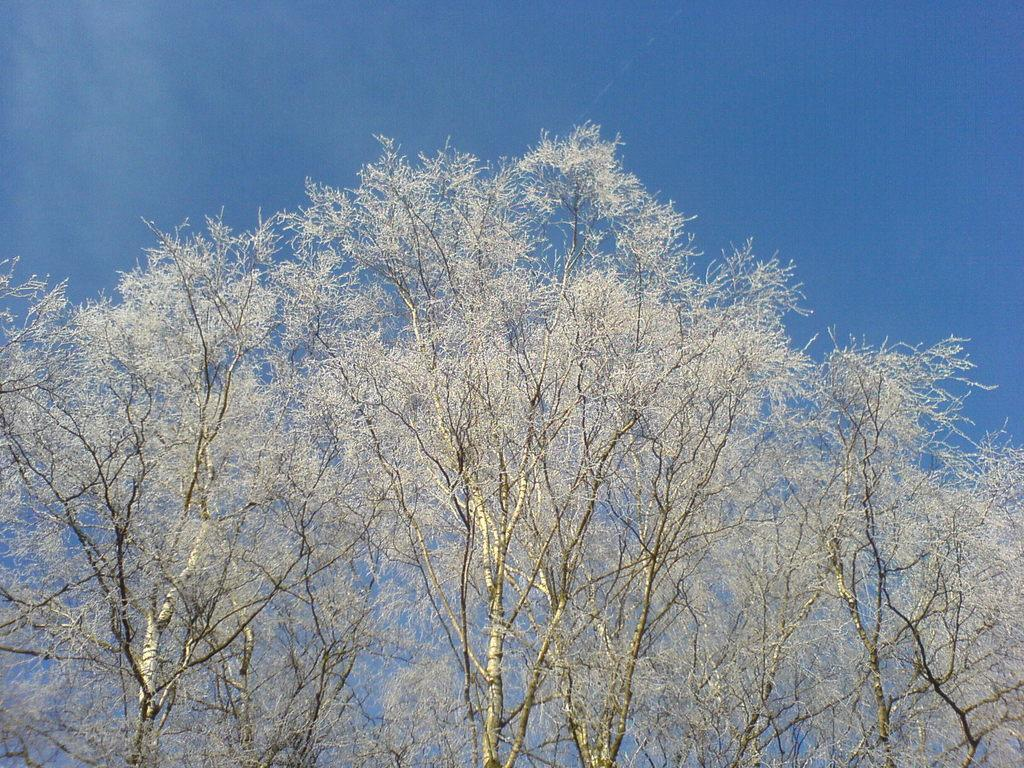What is located in the center of the image? There are trees in the center of the image. What can be seen in the background of the image? There is sky visible in the background of the image. What type of watch can be seen on the toes of the person in the image? There is no person or watch present in the image; it only features trees and sky. 